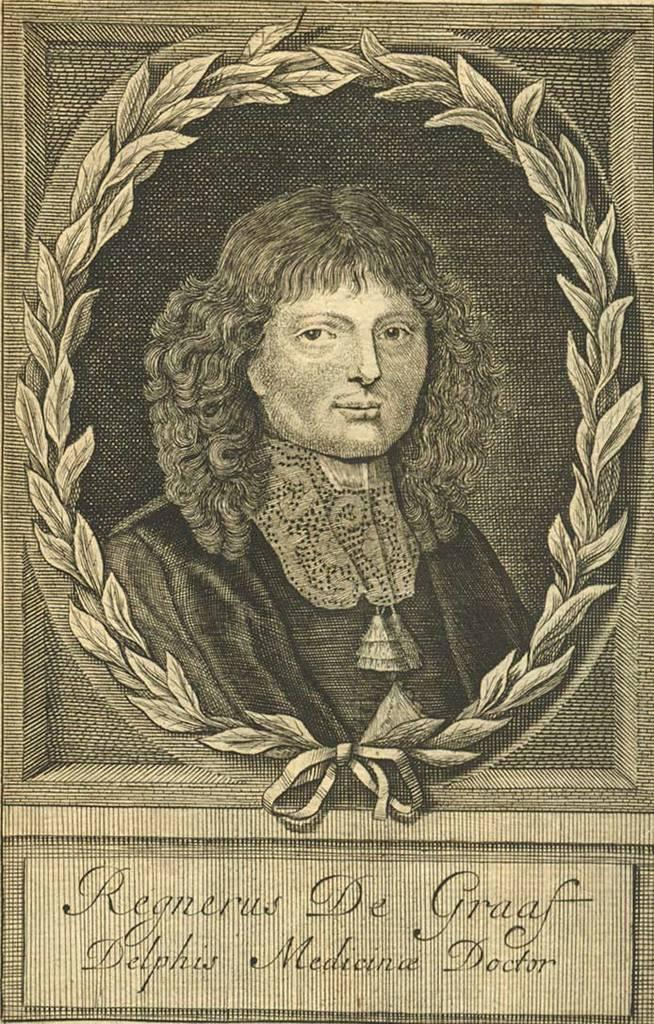What type of visual is the image? The image is a poster. What is shown on the poster? There is a depiction of a person on the poster. Are there any words on the poster? Yes, there is text on the poster. How many girls are shown baking pies in the image? There are no girls or pies depicted in the image; it features a person and text on a poster. 